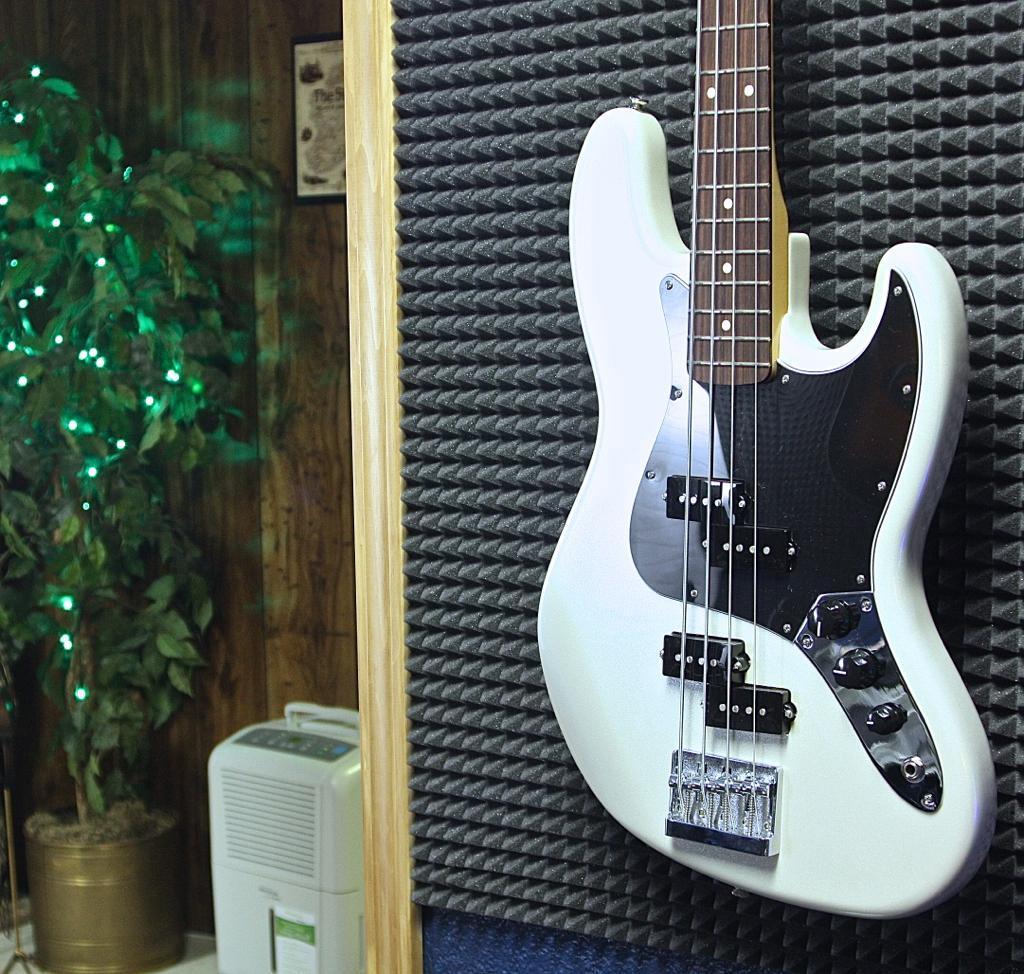In one or two sentences, can you explain what this image depicts? We can see guitar. On the background we can see wall,plant,pot. 